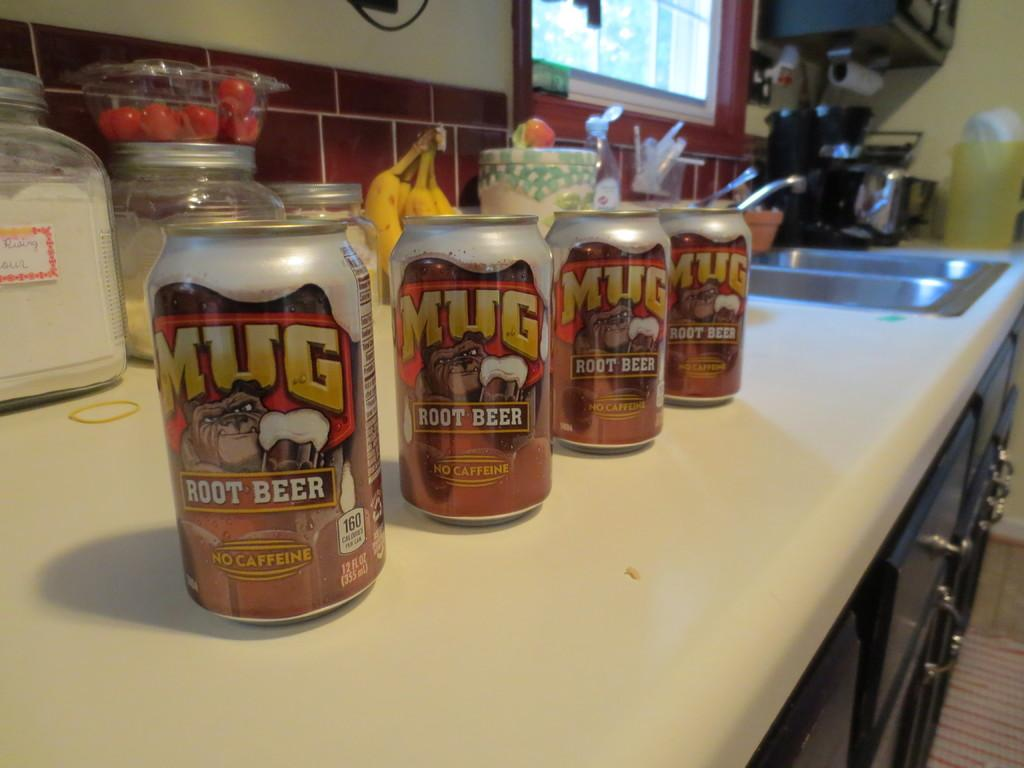How many tin bottles are visible in the image? There are 4 tin bottles in the image. What other containers can be seen in the image? There are jars in the image. What type of food items are present in the image? There are tomatoes and bananas in the image. What is the primary feature of the room in the image? There is a sink and cupboards in the image, suggesting it is a kitchen or food preparation area. What can be seen in the background of the image? There is a wall and a window in the background of the image. How many corks are on the floor in the image? There are no corks present in the image. What type of music instrument is being played by the girls in the image? There are no girls or guitar present in the image. 